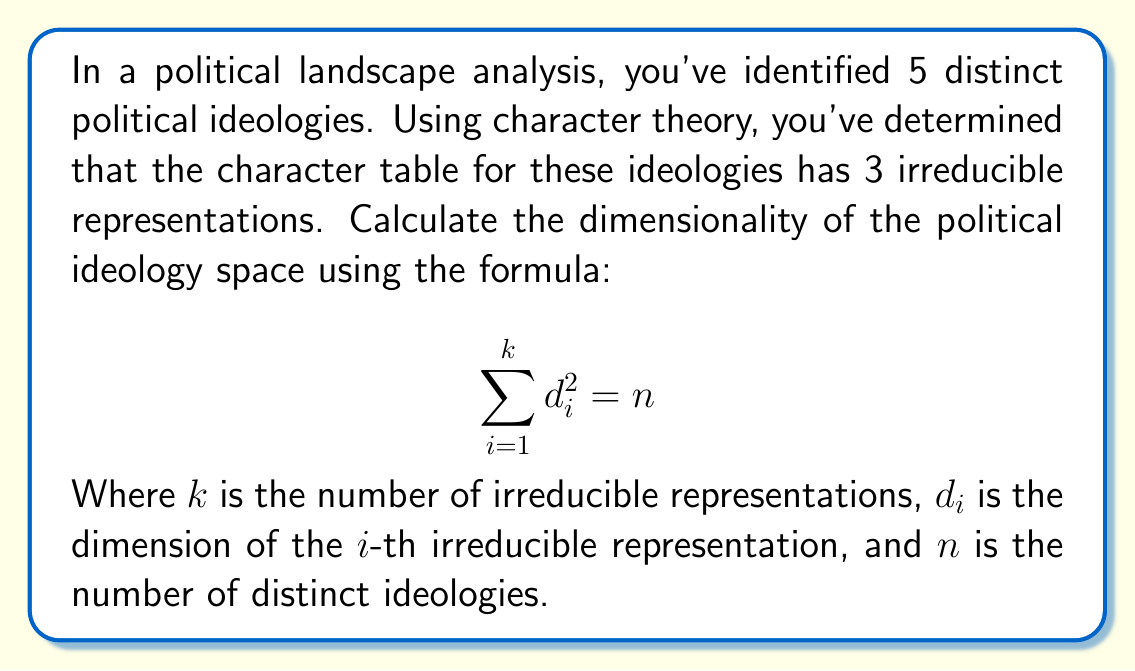Teach me how to tackle this problem. To solve this problem, we'll follow these steps:

1) We know that:
   - $n = 5$ (number of distinct ideologies)
   - $k = 3$ (number of irreducible representations)

2) We need to find $d_1$, $d_2$, and $d_3$ such that:

   $$ d_1^2 + d_2^2 + d_3^2 = 5 $$

3) In character theory, the dimensions of irreducible representations are always positive integers. 

4) The smallest possible dimensions that satisfy this equation are:

   $$ 1^2 + 1^2 + 1^2 = 3 $$
   
   However, this doesn't sum to 5.

5) The next possible combination is:

   $$ 1^2 + 1^2 + 2^2 = 1 + 1 + 4 = 6 $$
   
   This exceeds 5, so it's not correct.

6) The only combination of three squared integers that sums to 5 is:

   $$ 1^2 + 1^2 + \sqrt{3}^2 = 1 + 1 + 3 = 5 $$

7) However, $\sqrt{3}$ is not an integer, so this is not a valid solution in character theory.

8) Therefore, there is no valid solution with integer dimensions for the given constraints.

9) This suggests that the initial analysis of having 3 irreducible representations for 5 distinct ideologies is incorrect. In a valid character table, the number of irreducible representations should equal the number of conjugacy classes, which in this case should be 5.
Answer: The given constraints are inconsistent; a valid solution does not exist. 